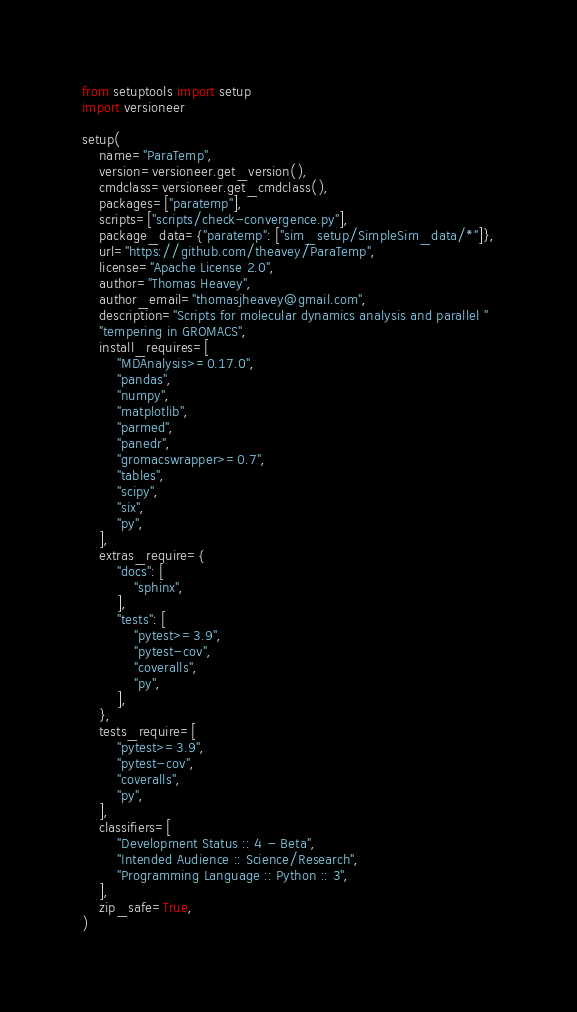<code> <loc_0><loc_0><loc_500><loc_500><_Python_>from setuptools import setup
import versioneer

setup(
    name="ParaTemp",
    version=versioneer.get_version(),
    cmdclass=versioneer.get_cmdclass(),
    packages=["paratemp"],
    scripts=["scripts/check-convergence.py"],
    package_data={"paratemp": ["sim_setup/SimpleSim_data/*"]},
    url="https://github.com/theavey/ParaTemp",
    license="Apache License 2.0",
    author="Thomas Heavey",
    author_email="thomasjheavey@gmail.com",
    description="Scripts for molecular dynamics analysis and parallel "
    "tempering in GROMACS",
    install_requires=[
        "MDAnalysis>=0.17.0",
        "pandas",
        "numpy",
        "matplotlib",
        "parmed",
        "panedr",
        "gromacswrapper>=0.7",
        "tables",
        "scipy",
        "six",
        "py",
    ],
    extras_require={
        "docs": [
            "sphinx",
        ],
        "tests": [
            "pytest>=3.9",
            "pytest-cov",
            "coveralls",
            "py",
        ],
    },
    tests_require=[
        "pytest>=3.9",
        "pytest-cov",
        "coveralls",
        "py",
    ],
    classifiers=[
        "Development Status :: 4 - Beta",
        "Intended Audience :: Science/Research",
        "Programming Language :: Python :: 3",
    ],
    zip_safe=True,
)
</code> 